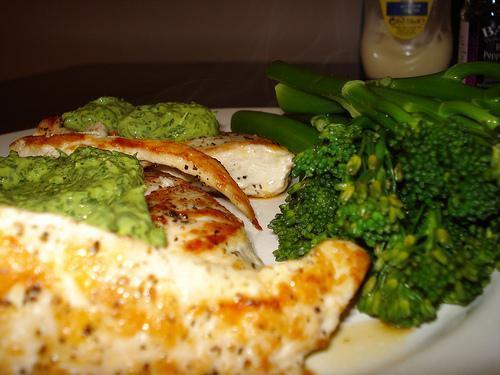How many plates are visible?
Give a very brief answer. 1. 